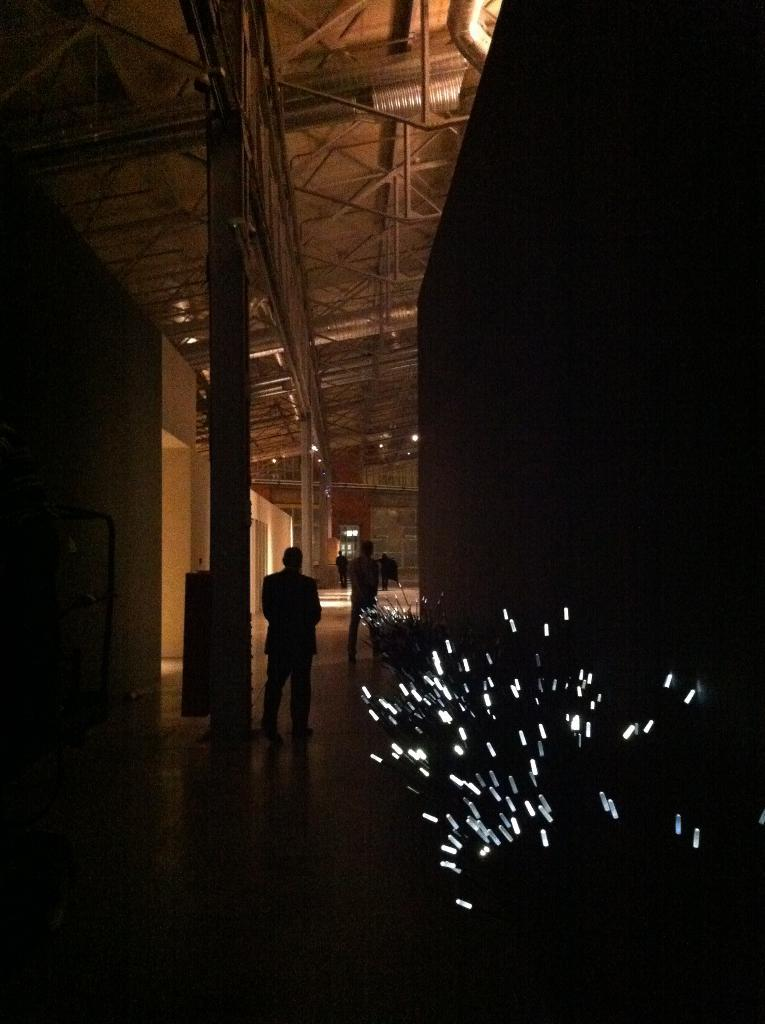What can be seen in the image that provides illumination? There are lights in the image. Who or what is located at the bottom of the image? There are people standing at the bottom of the image. What architectural features can be seen in the background of the image? There are pillars and a wall in the background of the image. What structure is visible at the top of the image? There is a roof visible at the top of the image. What type of question is being asked in the image? There is no question being asked in the image; it only contains lights, people, pillars, a wall, and a roof. On which side of the image are the restrooms located? There is no information about restrooms or sides in the image. 